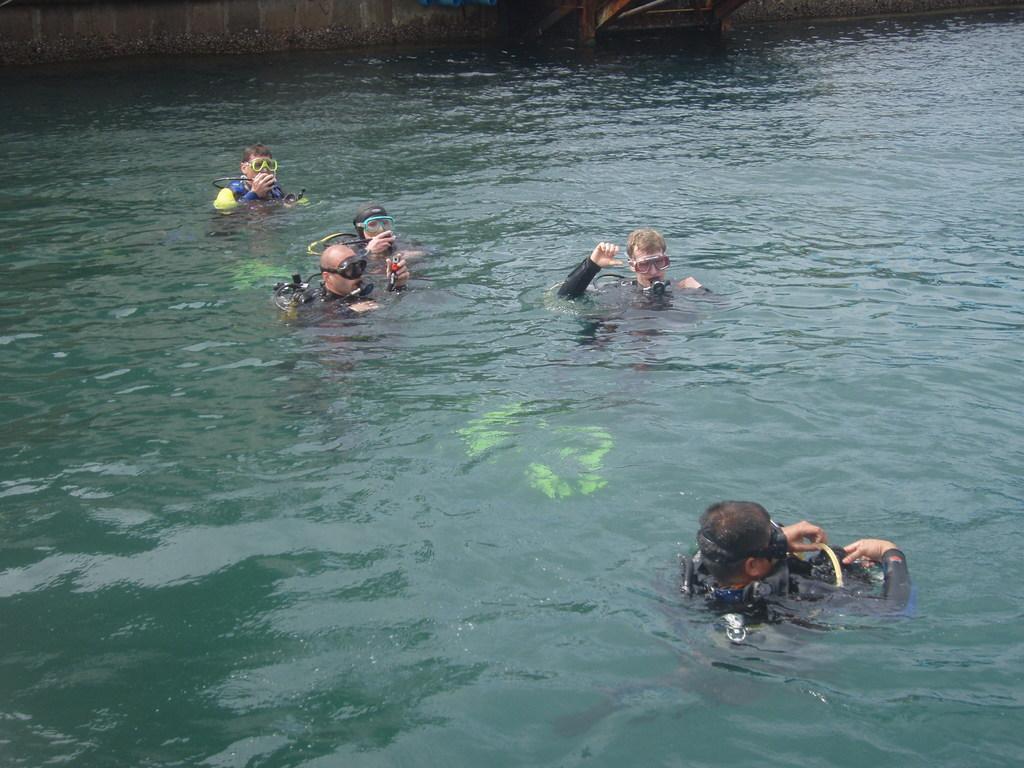How would you summarize this image in a sentence or two? In this picture we can see some group of people in the water with oxygen cylinder and wearing black swimming costumes. 